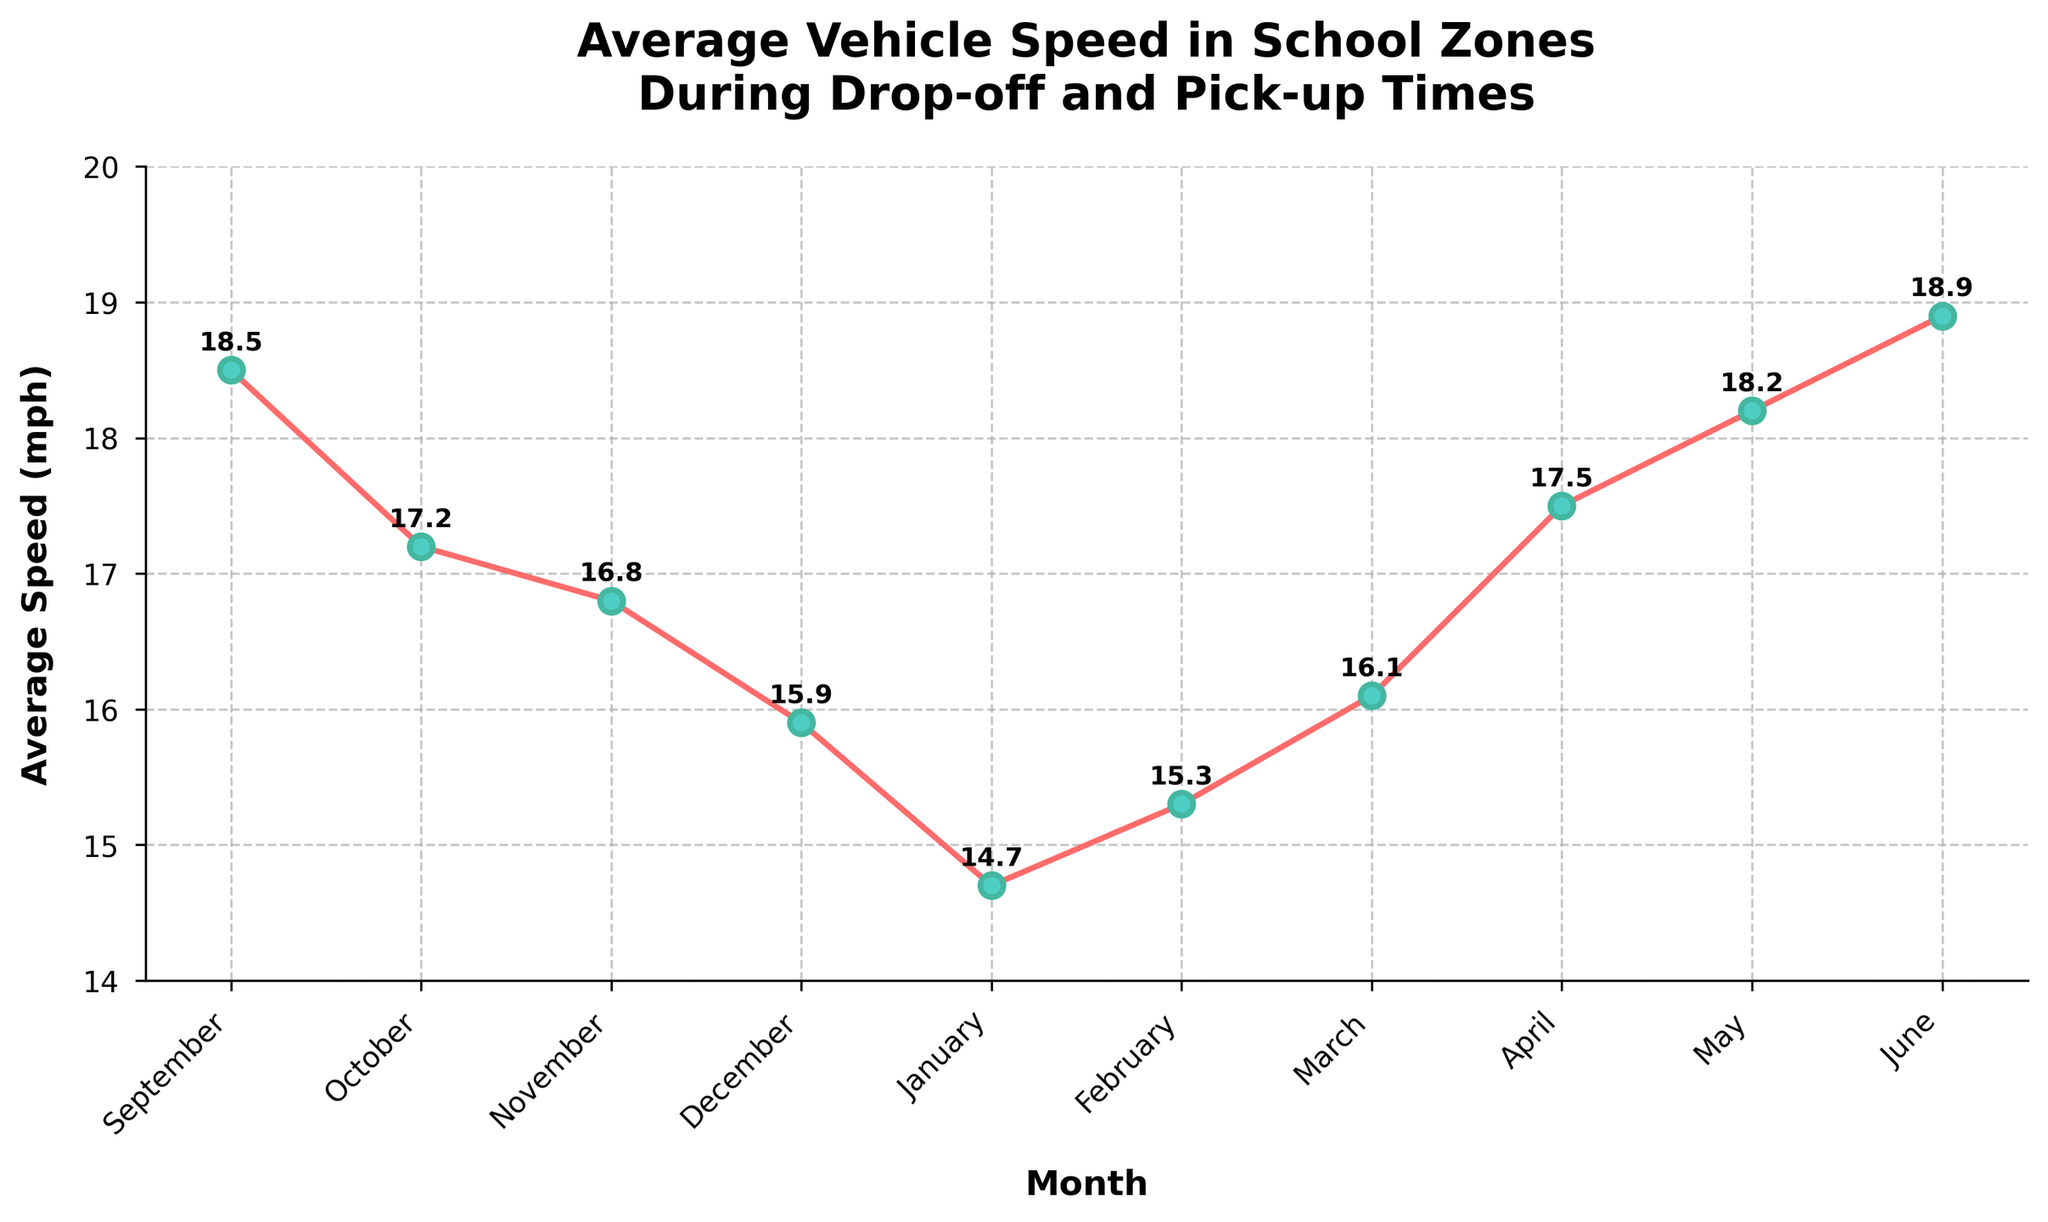What's the average vehicle speed in school zones in February? The plot shows the average vehicle speed for each month. For February, the point corresponds to 15.3 mph
Answer: 15.3 mph Which month had the lowest average vehicle speed in school zones? By examining the points on the plot, January is the lowest at 14.7 mph
Answer: January Which two consecutive months show the highest increase in average vehicle speed? Comparing the month-to-month changes, April to May shows the highest increase (17.5 mph to 18.2 mph)
Answer: April to May What is the range of average vehicle speeds in school zones across the academic year? The range is calculated by subtracting the minimum speed (14.7 mph in January) from the maximum speed (18.9 mph in June)
Answer: 4.2 mph How does the average vehicle speed in April compare to October? The plot shows that April has a higher average speed (17.5 mph) compared to October (17.2 mph)
Answer: April is higher In which months does the average vehicle speed stay below 17 mph? The months with speeds below 17 mph are November (16.8 mph), December (15.9 mph), January (14.7 mph), and February (15.3 mph)
Answer: November, December, January, February What's the overall trend of average vehicle speeds from September to June? Observing the plot, it shows a general decrease from September to January, then it increases again towards June
Answer: Decrease then increase What is the difference in average vehicle speed between the fastest and slowest month? The fastest month is June (18.9 mph) and the slowest is January (14.7 mph). The difference is 18.9 - 14.7
Answer: 4.2 mph How much did the average vehicle speed change from January to February? The speed increased from 14.7 mph in January to 15.3 mph in February, which is an increase of 15.3 - 14.7
Answer: 0.6 mph In which months is the average vehicle speed in school zones above 18 mph? The months with speeds above 18 mph are September (18.5 mph), May (18.2 mph), and June (18.9 mph)
Answer: September, May, June 